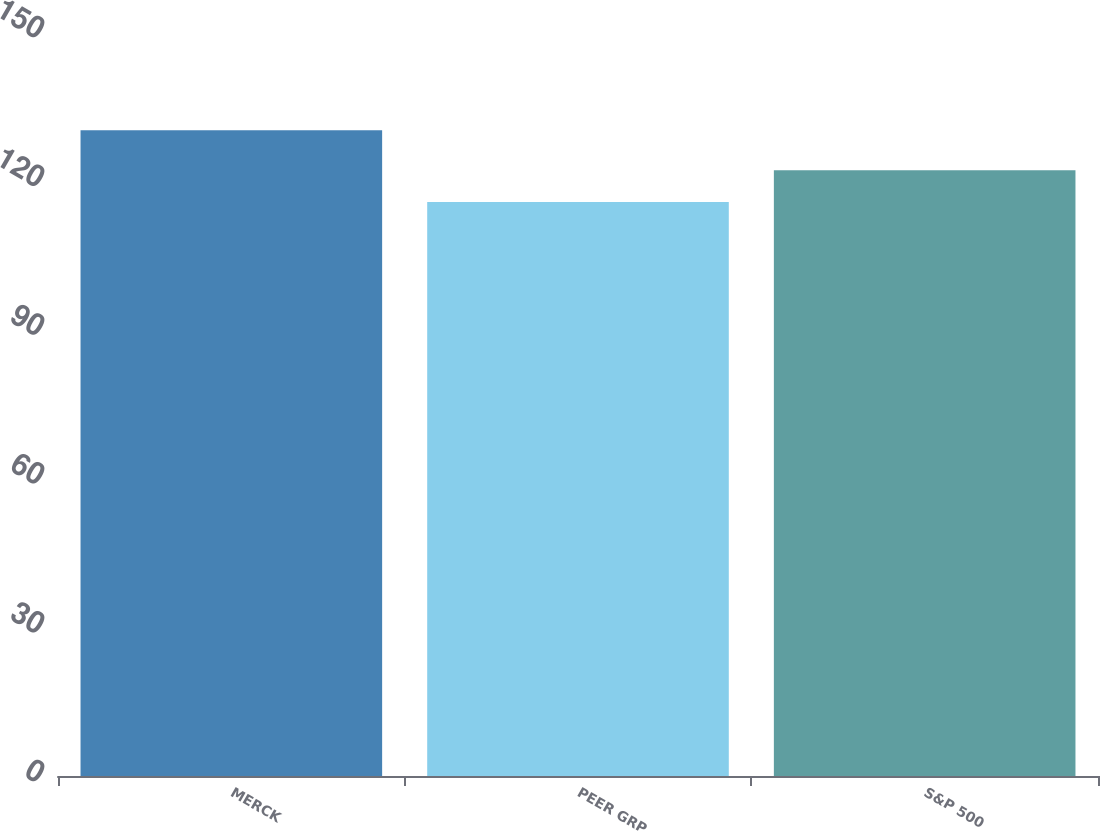Convert chart to OTSL. <chart><loc_0><loc_0><loc_500><loc_500><bar_chart><fcel>MERCK<fcel>PEER GRP<fcel>S&P 500<nl><fcel>130.18<fcel>115.73<fcel>122.14<nl></chart> 